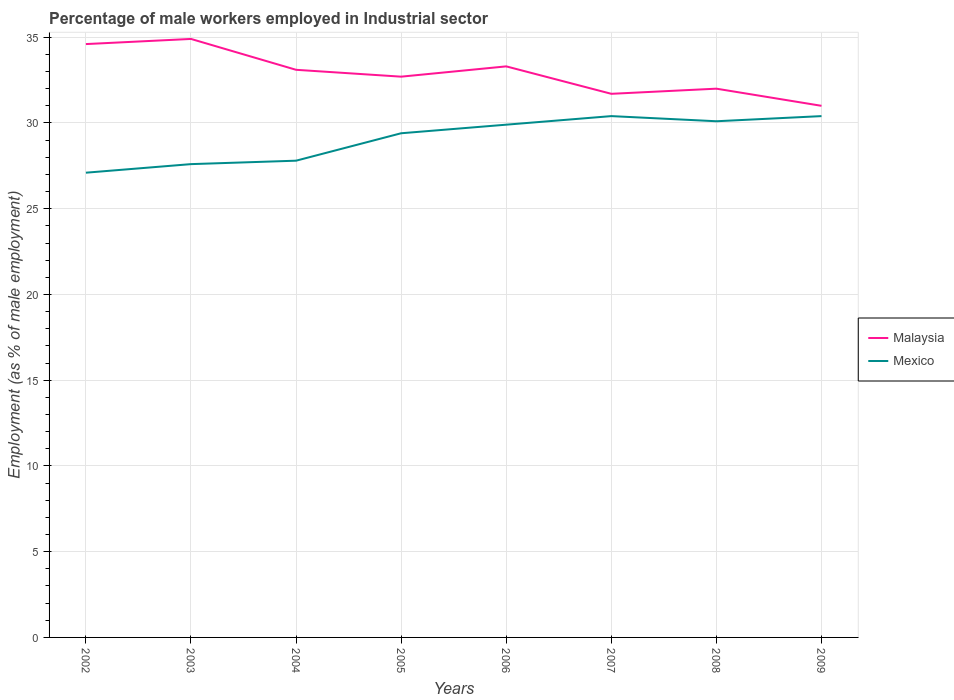Does the line corresponding to Malaysia intersect with the line corresponding to Mexico?
Give a very brief answer. No. Across all years, what is the maximum percentage of male workers employed in Industrial sector in Malaysia?
Provide a succinct answer. 31. In which year was the percentage of male workers employed in Industrial sector in Mexico maximum?
Keep it short and to the point. 2002. What is the difference between the highest and the second highest percentage of male workers employed in Industrial sector in Malaysia?
Offer a very short reply. 3.9. How many lines are there?
Keep it short and to the point. 2. Are the values on the major ticks of Y-axis written in scientific E-notation?
Keep it short and to the point. No. Does the graph contain any zero values?
Give a very brief answer. No. Does the graph contain grids?
Offer a very short reply. Yes. Where does the legend appear in the graph?
Give a very brief answer. Center right. How are the legend labels stacked?
Ensure brevity in your answer.  Vertical. What is the title of the graph?
Offer a very short reply. Percentage of male workers employed in Industrial sector. Does "Lesotho" appear as one of the legend labels in the graph?
Your answer should be very brief. No. What is the label or title of the X-axis?
Keep it short and to the point. Years. What is the label or title of the Y-axis?
Make the answer very short. Employment (as % of male employment). What is the Employment (as % of male employment) of Malaysia in 2002?
Make the answer very short. 34.6. What is the Employment (as % of male employment) of Mexico in 2002?
Provide a succinct answer. 27.1. What is the Employment (as % of male employment) in Malaysia in 2003?
Ensure brevity in your answer.  34.9. What is the Employment (as % of male employment) of Mexico in 2003?
Your answer should be very brief. 27.6. What is the Employment (as % of male employment) of Malaysia in 2004?
Keep it short and to the point. 33.1. What is the Employment (as % of male employment) in Mexico in 2004?
Provide a short and direct response. 27.8. What is the Employment (as % of male employment) of Malaysia in 2005?
Offer a very short reply. 32.7. What is the Employment (as % of male employment) in Mexico in 2005?
Your answer should be very brief. 29.4. What is the Employment (as % of male employment) in Malaysia in 2006?
Your answer should be very brief. 33.3. What is the Employment (as % of male employment) of Mexico in 2006?
Provide a short and direct response. 29.9. What is the Employment (as % of male employment) in Malaysia in 2007?
Ensure brevity in your answer.  31.7. What is the Employment (as % of male employment) in Mexico in 2007?
Offer a terse response. 30.4. What is the Employment (as % of male employment) of Malaysia in 2008?
Ensure brevity in your answer.  32. What is the Employment (as % of male employment) in Mexico in 2008?
Offer a very short reply. 30.1. What is the Employment (as % of male employment) of Malaysia in 2009?
Provide a short and direct response. 31. What is the Employment (as % of male employment) of Mexico in 2009?
Your answer should be compact. 30.4. Across all years, what is the maximum Employment (as % of male employment) of Malaysia?
Ensure brevity in your answer.  34.9. Across all years, what is the maximum Employment (as % of male employment) in Mexico?
Keep it short and to the point. 30.4. Across all years, what is the minimum Employment (as % of male employment) in Malaysia?
Your answer should be compact. 31. Across all years, what is the minimum Employment (as % of male employment) of Mexico?
Provide a succinct answer. 27.1. What is the total Employment (as % of male employment) of Malaysia in the graph?
Give a very brief answer. 263.3. What is the total Employment (as % of male employment) in Mexico in the graph?
Your answer should be very brief. 232.7. What is the difference between the Employment (as % of male employment) in Mexico in 2002 and that in 2003?
Give a very brief answer. -0.5. What is the difference between the Employment (as % of male employment) of Malaysia in 2002 and that in 2004?
Provide a short and direct response. 1.5. What is the difference between the Employment (as % of male employment) of Malaysia in 2002 and that in 2006?
Provide a short and direct response. 1.3. What is the difference between the Employment (as % of male employment) of Malaysia in 2002 and that in 2007?
Ensure brevity in your answer.  2.9. What is the difference between the Employment (as % of male employment) in Malaysia in 2002 and that in 2008?
Give a very brief answer. 2.6. What is the difference between the Employment (as % of male employment) in Mexico in 2003 and that in 2004?
Provide a succinct answer. -0.2. What is the difference between the Employment (as % of male employment) in Mexico in 2003 and that in 2006?
Provide a succinct answer. -2.3. What is the difference between the Employment (as % of male employment) in Mexico in 2003 and that in 2007?
Give a very brief answer. -2.8. What is the difference between the Employment (as % of male employment) in Mexico in 2003 and that in 2009?
Provide a succinct answer. -2.8. What is the difference between the Employment (as % of male employment) in Mexico in 2004 and that in 2005?
Offer a very short reply. -1.6. What is the difference between the Employment (as % of male employment) in Mexico in 2004 and that in 2006?
Give a very brief answer. -2.1. What is the difference between the Employment (as % of male employment) of Mexico in 2004 and that in 2009?
Keep it short and to the point. -2.6. What is the difference between the Employment (as % of male employment) in Malaysia in 2005 and that in 2006?
Your response must be concise. -0.6. What is the difference between the Employment (as % of male employment) of Mexico in 2005 and that in 2007?
Ensure brevity in your answer.  -1. What is the difference between the Employment (as % of male employment) in Mexico in 2005 and that in 2008?
Offer a terse response. -0.7. What is the difference between the Employment (as % of male employment) of Mexico in 2005 and that in 2009?
Provide a short and direct response. -1. What is the difference between the Employment (as % of male employment) in Malaysia in 2006 and that in 2007?
Your response must be concise. 1.6. What is the difference between the Employment (as % of male employment) in Mexico in 2006 and that in 2007?
Provide a short and direct response. -0.5. What is the difference between the Employment (as % of male employment) of Malaysia in 2007 and that in 2008?
Your answer should be very brief. -0.3. What is the difference between the Employment (as % of male employment) in Mexico in 2007 and that in 2009?
Offer a very short reply. 0. What is the difference between the Employment (as % of male employment) of Malaysia in 2008 and that in 2009?
Offer a very short reply. 1. What is the difference between the Employment (as % of male employment) in Mexico in 2008 and that in 2009?
Keep it short and to the point. -0.3. What is the difference between the Employment (as % of male employment) of Malaysia in 2002 and the Employment (as % of male employment) of Mexico in 2003?
Offer a terse response. 7. What is the difference between the Employment (as % of male employment) in Malaysia in 2002 and the Employment (as % of male employment) in Mexico in 2004?
Your response must be concise. 6.8. What is the difference between the Employment (as % of male employment) of Malaysia in 2002 and the Employment (as % of male employment) of Mexico in 2005?
Offer a very short reply. 5.2. What is the difference between the Employment (as % of male employment) in Malaysia in 2002 and the Employment (as % of male employment) in Mexico in 2006?
Provide a succinct answer. 4.7. What is the difference between the Employment (as % of male employment) of Malaysia in 2002 and the Employment (as % of male employment) of Mexico in 2007?
Your answer should be compact. 4.2. What is the difference between the Employment (as % of male employment) in Malaysia in 2002 and the Employment (as % of male employment) in Mexico in 2008?
Make the answer very short. 4.5. What is the difference between the Employment (as % of male employment) of Malaysia in 2003 and the Employment (as % of male employment) of Mexico in 2006?
Provide a short and direct response. 5. What is the difference between the Employment (as % of male employment) of Malaysia in 2003 and the Employment (as % of male employment) of Mexico in 2009?
Ensure brevity in your answer.  4.5. What is the difference between the Employment (as % of male employment) in Malaysia in 2004 and the Employment (as % of male employment) in Mexico in 2005?
Ensure brevity in your answer.  3.7. What is the difference between the Employment (as % of male employment) of Malaysia in 2004 and the Employment (as % of male employment) of Mexico in 2008?
Ensure brevity in your answer.  3. What is the difference between the Employment (as % of male employment) in Malaysia in 2005 and the Employment (as % of male employment) in Mexico in 2007?
Your response must be concise. 2.3. What is the difference between the Employment (as % of male employment) of Malaysia in 2005 and the Employment (as % of male employment) of Mexico in 2009?
Offer a very short reply. 2.3. What is the difference between the Employment (as % of male employment) of Malaysia in 2006 and the Employment (as % of male employment) of Mexico in 2007?
Provide a succinct answer. 2.9. What is the difference between the Employment (as % of male employment) in Malaysia in 2006 and the Employment (as % of male employment) in Mexico in 2008?
Keep it short and to the point. 3.2. What is the difference between the Employment (as % of male employment) in Malaysia in 2007 and the Employment (as % of male employment) in Mexico in 2009?
Your answer should be very brief. 1.3. What is the average Employment (as % of male employment) in Malaysia per year?
Provide a succinct answer. 32.91. What is the average Employment (as % of male employment) of Mexico per year?
Keep it short and to the point. 29.09. In the year 2003, what is the difference between the Employment (as % of male employment) of Malaysia and Employment (as % of male employment) of Mexico?
Your answer should be compact. 7.3. In the year 2004, what is the difference between the Employment (as % of male employment) of Malaysia and Employment (as % of male employment) of Mexico?
Provide a succinct answer. 5.3. In the year 2005, what is the difference between the Employment (as % of male employment) in Malaysia and Employment (as % of male employment) in Mexico?
Make the answer very short. 3.3. In the year 2007, what is the difference between the Employment (as % of male employment) in Malaysia and Employment (as % of male employment) in Mexico?
Provide a short and direct response. 1.3. In the year 2009, what is the difference between the Employment (as % of male employment) in Malaysia and Employment (as % of male employment) in Mexico?
Your answer should be very brief. 0.6. What is the ratio of the Employment (as % of male employment) of Malaysia in 2002 to that in 2003?
Offer a terse response. 0.99. What is the ratio of the Employment (as % of male employment) in Mexico in 2002 to that in 2003?
Offer a terse response. 0.98. What is the ratio of the Employment (as % of male employment) of Malaysia in 2002 to that in 2004?
Your response must be concise. 1.05. What is the ratio of the Employment (as % of male employment) of Mexico in 2002 to that in 2004?
Ensure brevity in your answer.  0.97. What is the ratio of the Employment (as % of male employment) in Malaysia in 2002 to that in 2005?
Ensure brevity in your answer.  1.06. What is the ratio of the Employment (as % of male employment) of Mexico in 2002 to that in 2005?
Make the answer very short. 0.92. What is the ratio of the Employment (as % of male employment) in Malaysia in 2002 to that in 2006?
Offer a terse response. 1.04. What is the ratio of the Employment (as % of male employment) of Mexico in 2002 to that in 2006?
Offer a very short reply. 0.91. What is the ratio of the Employment (as % of male employment) of Malaysia in 2002 to that in 2007?
Provide a succinct answer. 1.09. What is the ratio of the Employment (as % of male employment) in Mexico in 2002 to that in 2007?
Your answer should be compact. 0.89. What is the ratio of the Employment (as % of male employment) of Malaysia in 2002 to that in 2008?
Offer a very short reply. 1.08. What is the ratio of the Employment (as % of male employment) in Mexico in 2002 to that in 2008?
Keep it short and to the point. 0.9. What is the ratio of the Employment (as % of male employment) of Malaysia in 2002 to that in 2009?
Your answer should be very brief. 1.12. What is the ratio of the Employment (as % of male employment) in Mexico in 2002 to that in 2009?
Your answer should be very brief. 0.89. What is the ratio of the Employment (as % of male employment) of Malaysia in 2003 to that in 2004?
Ensure brevity in your answer.  1.05. What is the ratio of the Employment (as % of male employment) in Malaysia in 2003 to that in 2005?
Your response must be concise. 1.07. What is the ratio of the Employment (as % of male employment) of Mexico in 2003 to that in 2005?
Provide a succinct answer. 0.94. What is the ratio of the Employment (as % of male employment) in Malaysia in 2003 to that in 2006?
Make the answer very short. 1.05. What is the ratio of the Employment (as % of male employment) of Mexico in 2003 to that in 2006?
Keep it short and to the point. 0.92. What is the ratio of the Employment (as % of male employment) of Malaysia in 2003 to that in 2007?
Give a very brief answer. 1.1. What is the ratio of the Employment (as % of male employment) in Mexico in 2003 to that in 2007?
Ensure brevity in your answer.  0.91. What is the ratio of the Employment (as % of male employment) in Malaysia in 2003 to that in 2008?
Provide a short and direct response. 1.09. What is the ratio of the Employment (as % of male employment) of Mexico in 2003 to that in 2008?
Ensure brevity in your answer.  0.92. What is the ratio of the Employment (as % of male employment) in Malaysia in 2003 to that in 2009?
Your answer should be very brief. 1.13. What is the ratio of the Employment (as % of male employment) in Mexico in 2003 to that in 2009?
Your answer should be very brief. 0.91. What is the ratio of the Employment (as % of male employment) in Malaysia in 2004 to that in 2005?
Your answer should be compact. 1.01. What is the ratio of the Employment (as % of male employment) of Mexico in 2004 to that in 2005?
Your answer should be compact. 0.95. What is the ratio of the Employment (as % of male employment) in Mexico in 2004 to that in 2006?
Your answer should be compact. 0.93. What is the ratio of the Employment (as % of male employment) of Malaysia in 2004 to that in 2007?
Your answer should be compact. 1.04. What is the ratio of the Employment (as % of male employment) in Mexico in 2004 to that in 2007?
Provide a short and direct response. 0.91. What is the ratio of the Employment (as % of male employment) of Malaysia in 2004 to that in 2008?
Your response must be concise. 1.03. What is the ratio of the Employment (as % of male employment) of Mexico in 2004 to that in 2008?
Ensure brevity in your answer.  0.92. What is the ratio of the Employment (as % of male employment) in Malaysia in 2004 to that in 2009?
Your response must be concise. 1.07. What is the ratio of the Employment (as % of male employment) of Mexico in 2004 to that in 2009?
Make the answer very short. 0.91. What is the ratio of the Employment (as % of male employment) of Malaysia in 2005 to that in 2006?
Provide a succinct answer. 0.98. What is the ratio of the Employment (as % of male employment) of Mexico in 2005 to that in 2006?
Your response must be concise. 0.98. What is the ratio of the Employment (as % of male employment) of Malaysia in 2005 to that in 2007?
Ensure brevity in your answer.  1.03. What is the ratio of the Employment (as % of male employment) of Mexico in 2005 to that in 2007?
Make the answer very short. 0.97. What is the ratio of the Employment (as % of male employment) of Malaysia in 2005 to that in 2008?
Provide a short and direct response. 1.02. What is the ratio of the Employment (as % of male employment) of Mexico in 2005 to that in 2008?
Ensure brevity in your answer.  0.98. What is the ratio of the Employment (as % of male employment) of Malaysia in 2005 to that in 2009?
Your answer should be very brief. 1.05. What is the ratio of the Employment (as % of male employment) of Mexico in 2005 to that in 2009?
Ensure brevity in your answer.  0.97. What is the ratio of the Employment (as % of male employment) in Malaysia in 2006 to that in 2007?
Your answer should be compact. 1.05. What is the ratio of the Employment (as % of male employment) of Mexico in 2006 to that in 2007?
Offer a terse response. 0.98. What is the ratio of the Employment (as % of male employment) in Malaysia in 2006 to that in 2008?
Give a very brief answer. 1.04. What is the ratio of the Employment (as % of male employment) of Mexico in 2006 to that in 2008?
Your answer should be very brief. 0.99. What is the ratio of the Employment (as % of male employment) of Malaysia in 2006 to that in 2009?
Make the answer very short. 1.07. What is the ratio of the Employment (as % of male employment) of Mexico in 2006 to that in 2009?
Give a very brief answer. 0.98. What is the ratio of the Employment (as % of male employment) in Malaysia in 2007 to that in 2008?
Your answer should be compact. 0.99. What is the ratio of the Employment (as % of male employment) in Malaysia in 2007 to that in 2009?
Your response must be concise. 1.02. What is the ratio of the Employment (as % of male employment) of Mexico in 2007 to that in 2009?
Ensure brevity in your answer.  1. What is the ratio of the Employment (as % of male employment) in Malaysia in 2008 to that in 2009?
Your answer should be very brief. 1.03. What is the difference between the highest and the lowest Employment (as % of male employment) in Malaysia?
Make the answer very short. 3.9. 